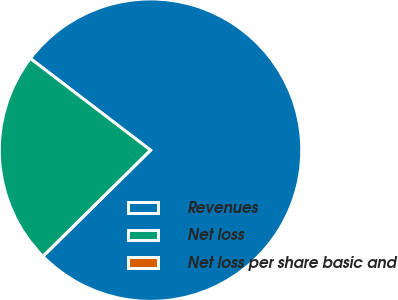Convert chart. <chart><loc_0><loc_0><loc_500><loc_500><pie_chart><fcel>Revenues<fcel>Net loss<fcel>Net loss per share basic and<nl><fcel>77.23%<fcel>22.77%<fcel>0.0%<nl></chart> 